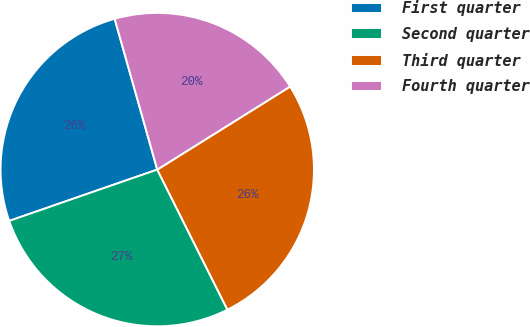Convert chart. <chart><loc_0><loc_0><loc_500><loc_500><pie_chart><fcel>First quarter<fcel>Second quarter<fcel>Third quarter<fcel>Fourth quarter<nl><fcel>25.93%<fcel>27.08%<fcel>26.5%<fcel>20.49%<nl></chart> 